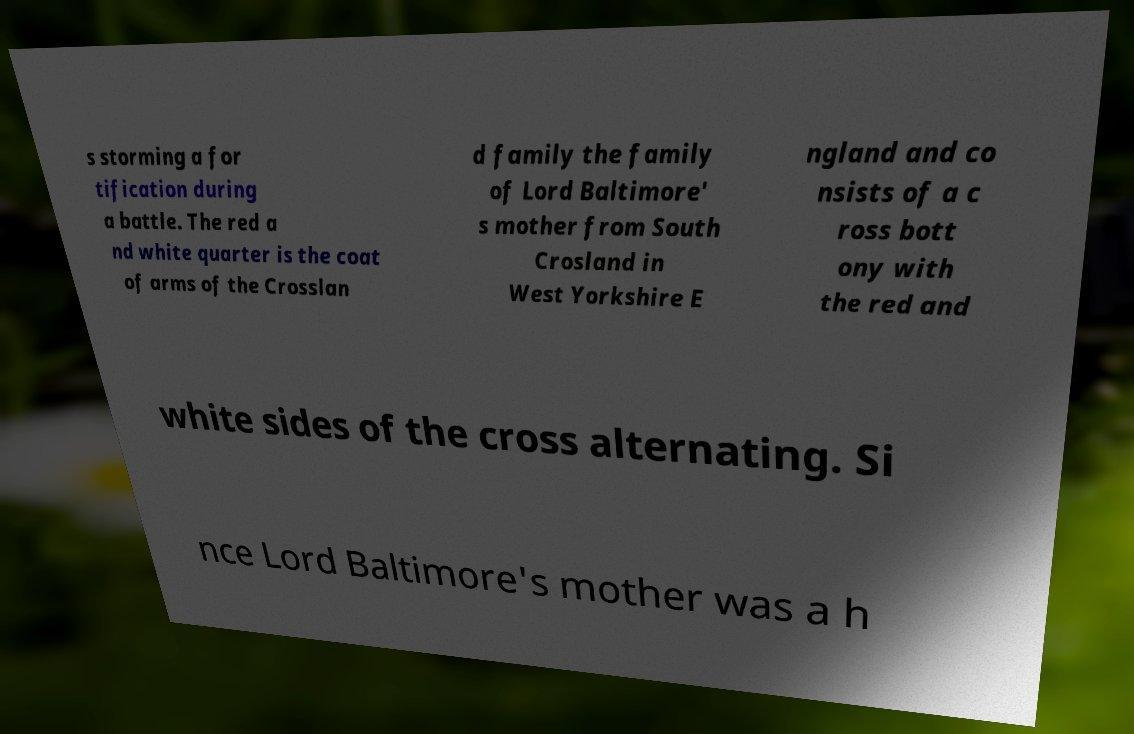I need the written content from this picture converted into text. Can you do that? s storming a for tification during a battle. The red a nd white quarter is the coat of arms of the Crosslan d family the family of Lord Baltimore' s mother from South Crosland in West Yorkshire E ngland and co nsists of a c ross bott ony with the red and white sides of the cross alternating. Si nce Lord Baltimore's mother was a h 